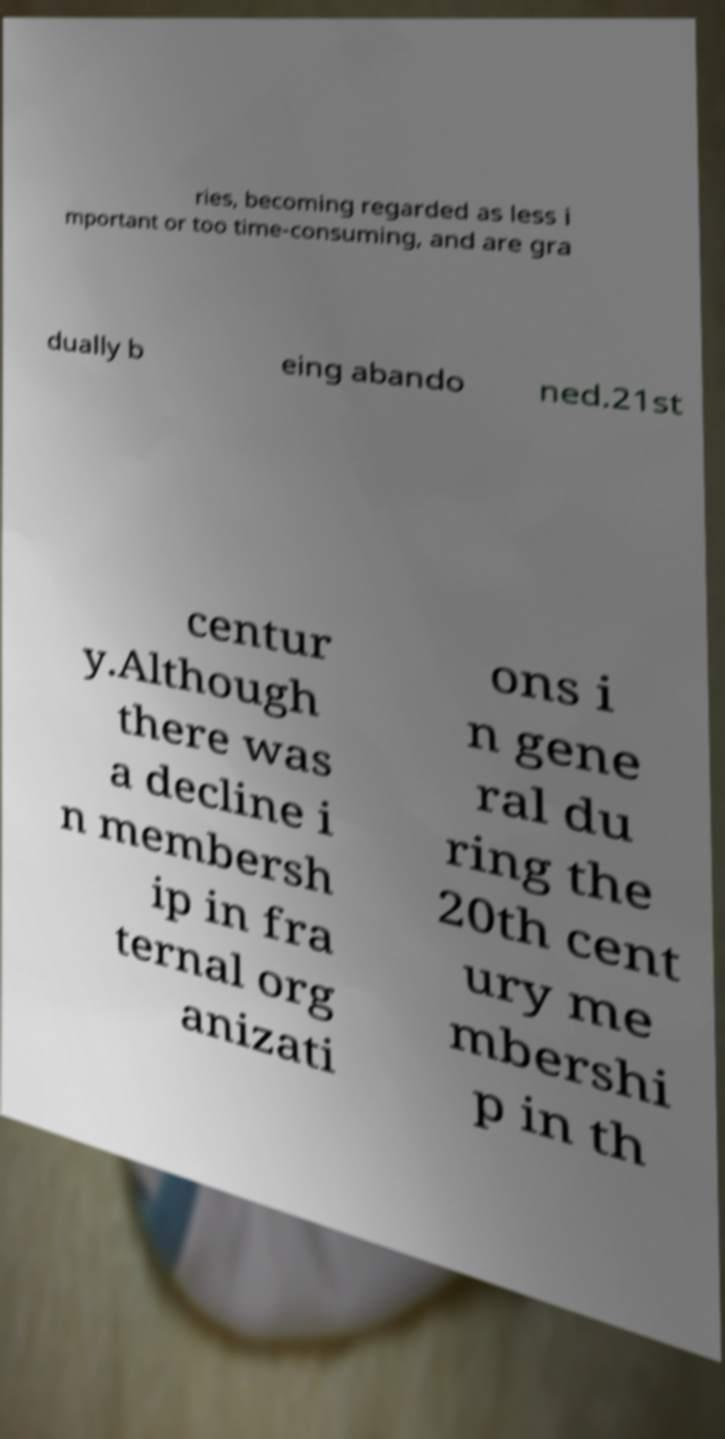Could you extract and type out the text from this image? ries, becoming regarded as less i mportant or too time-consuming, and are gra dually b eing abando ned.21st centur y.Although there was a decline i n membersh ip in fra ternal org anizati ons i n gene ral du ring the 20th cent ury me mbershi p in th 